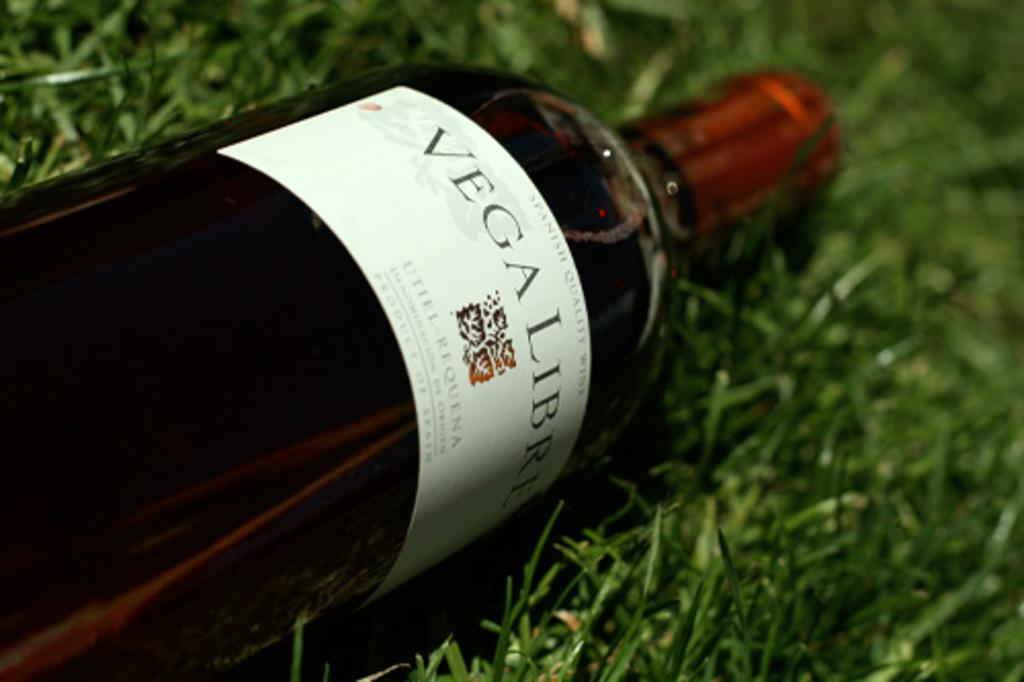<image>
Share a concise interpretation of the image provided. A bottle of "VEGALIBRE" is on the ground. 